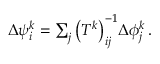<formula> <loc_0><loc_0><loc_500><loc_500>\begin{array} { r } { \Delta { \psi } _ { i } ^ { k } = \sum _ { j } \left ( T ^ { k } \right ) _ { i j } ^ { - 1 } \Delta { \phi } _ { j } ^ { k } \, . } \end{array}</formula> 